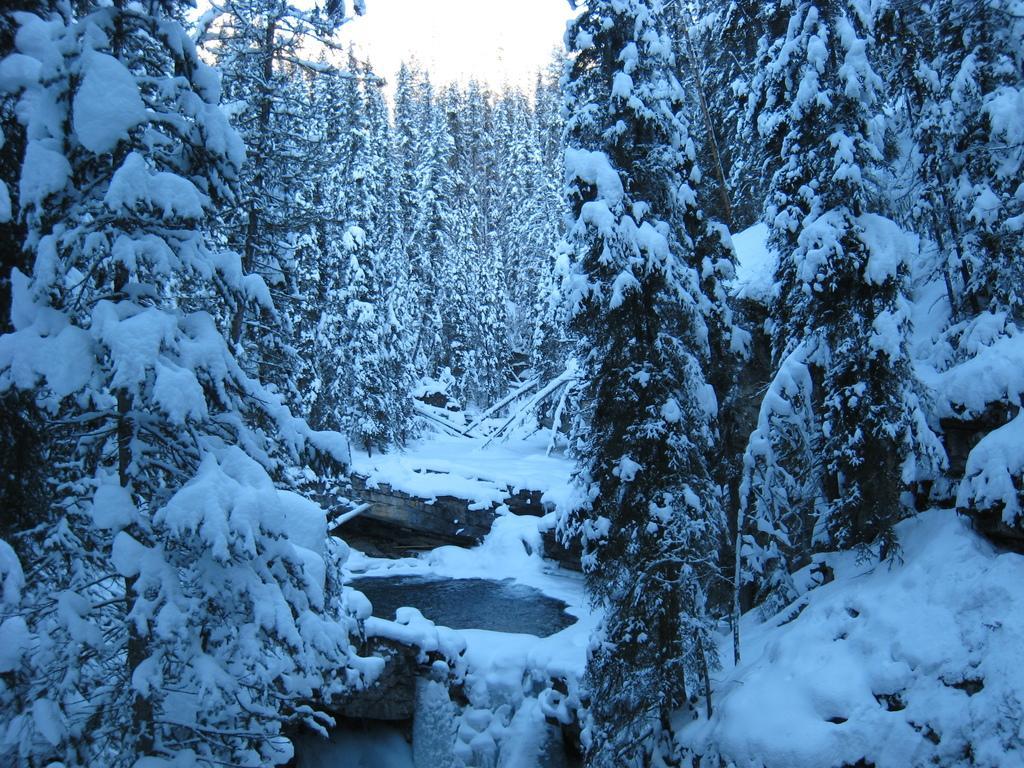Please provide a concise description of this image. In this picture we can see trees covered with snow and water. In the background of the image we can see sky. 